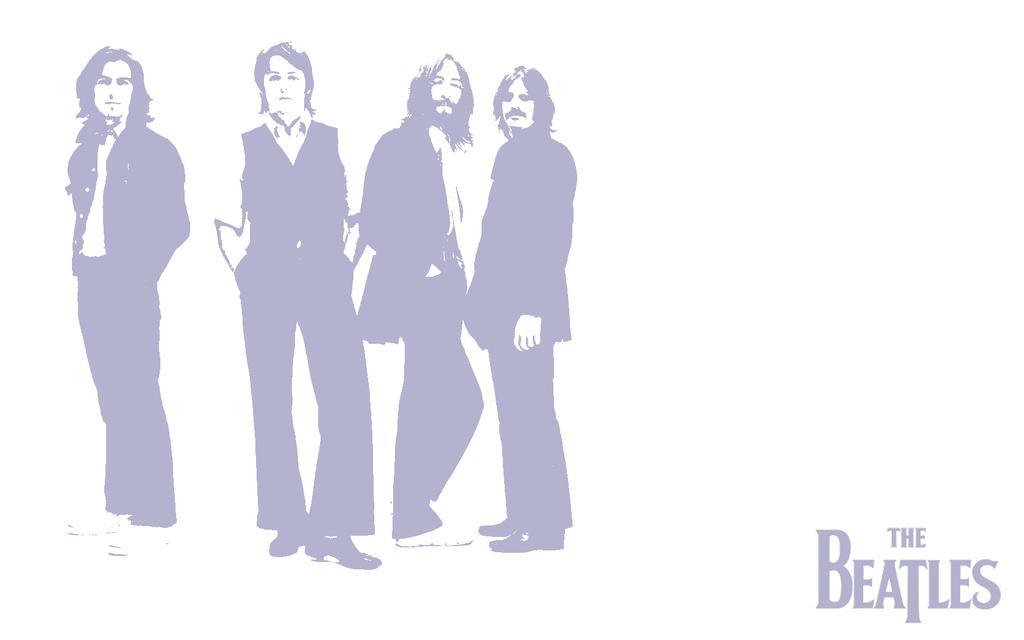What is the main subject of the image? The main subject of the image is a group of persons standing on the left side. Where is the text located in the image? The text is on the right side of the image. What type of mint can be seen growing near the group of persons in the image? There is no mint visible in the image; it only features a group of persons standing on the left side and text on the right side. 